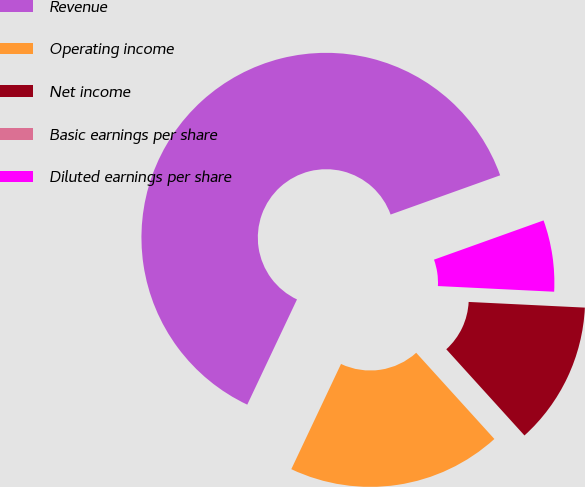Convert chart to OTSL. <chart><loc_0><loc_0><loc_500><loc_500><pie_chart><fcel>Revenue<fcel>Operating income<fcel>Net income<fcel>Basic earnings per share<fcel>Diluted earnings per share<nl><fcel>62.5%<fcel>18.75%<fcel>12.5%<fcel>0.0%<fcel>6.25%<nl></chart> 